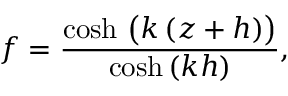Convert formula to latex. <formula><loc_0><loc_0><loc_500><loc_500>f = { \frac { \cosh \, { \left ( } k \, ( z + h ) { \right ) } } { \cosh \, ( k h ) } } ,</formula> 